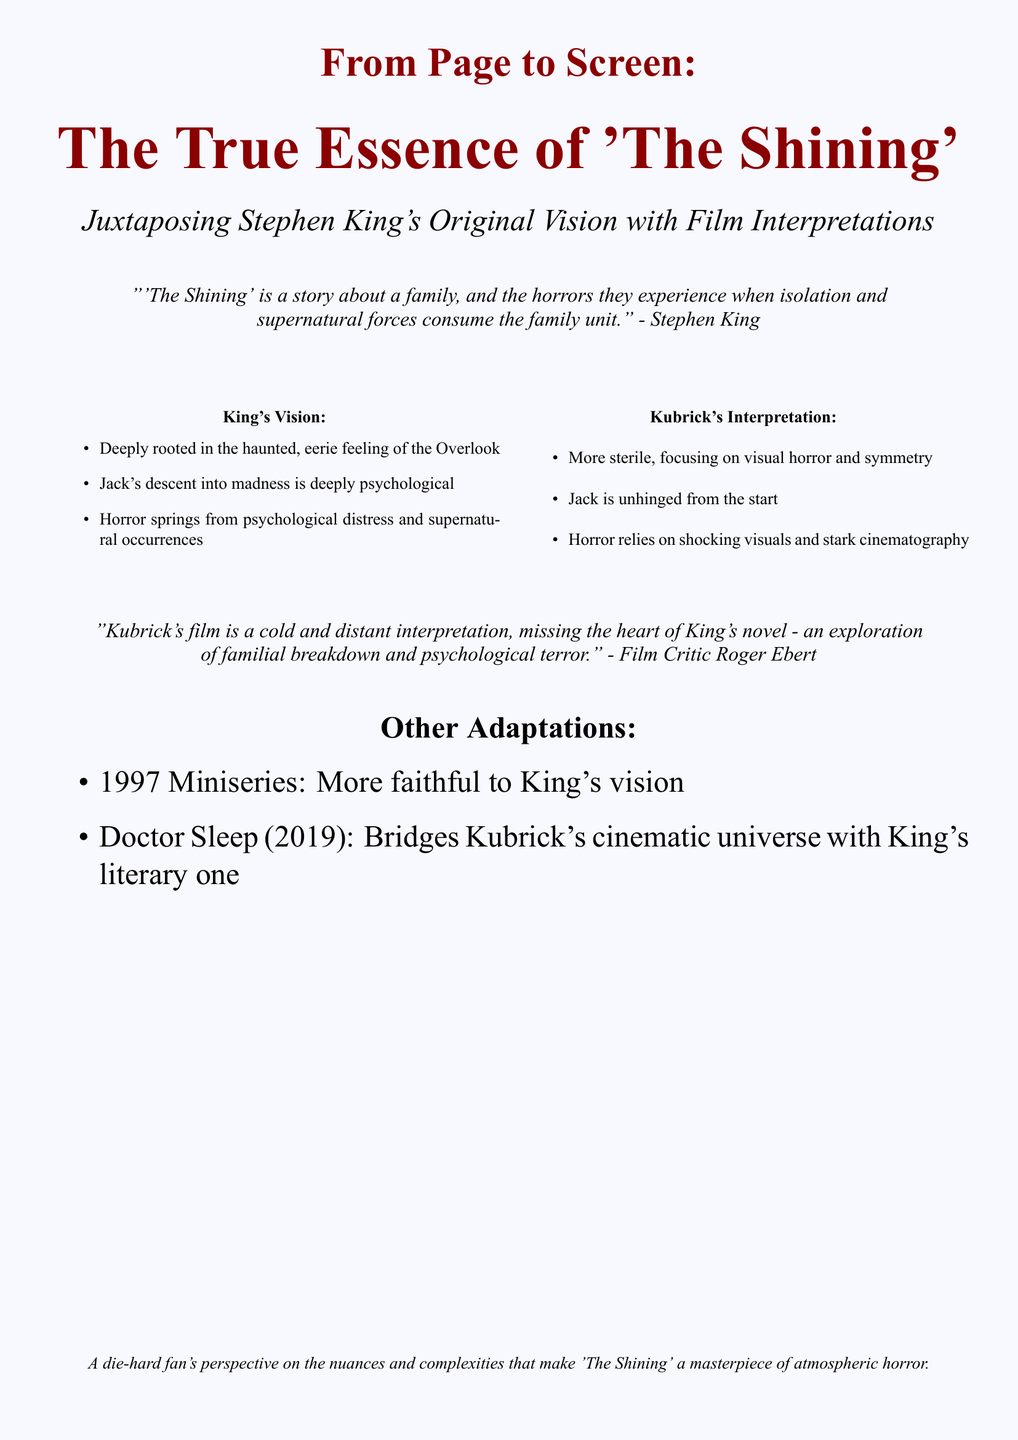What is the title of the document? The title of the document is prominently displayed at the top of the cover.
Answer: From Page to Screen: The True Essence of 'The Shining' Who is the original author of 'The Shining'? The document refers to Stephen King as the original author of 'The Shining'.
Answer: Stephen King What year was the adaptation of 'Doctor Sleep' released? The document lists the year of release for 'Doctor Sleep' as part of the other adaptations section.
Answer: 2019 Which critic mentioned Kubrick's interpretation of the film? The document quotes a critique specifically mentioning Kubrick's interpretation.
Answer: Roger Ebert What is the primary theme explored in King's version of 'The Shining'? The document summarizes the main themes of King's vision in the context of family and horror.
Answer: Familial breakdown How does Kubrick's interpretation differ from King's vision? The document contrasts Kubrick's focus with King's psychological depth and themes.
Answer: Visual horror and symmetry What adaptation is identified as more faithful to King's vision? The document lists an adaptation that aligns closely with King's narrative and themes.
Answer: 1997 Miniseries What type of horror elements resonate with readers according to the document? The document mentions elements that create a haunting atmosphere and psychological impact on readers.
Answer: Atmospheric and psychological horror 